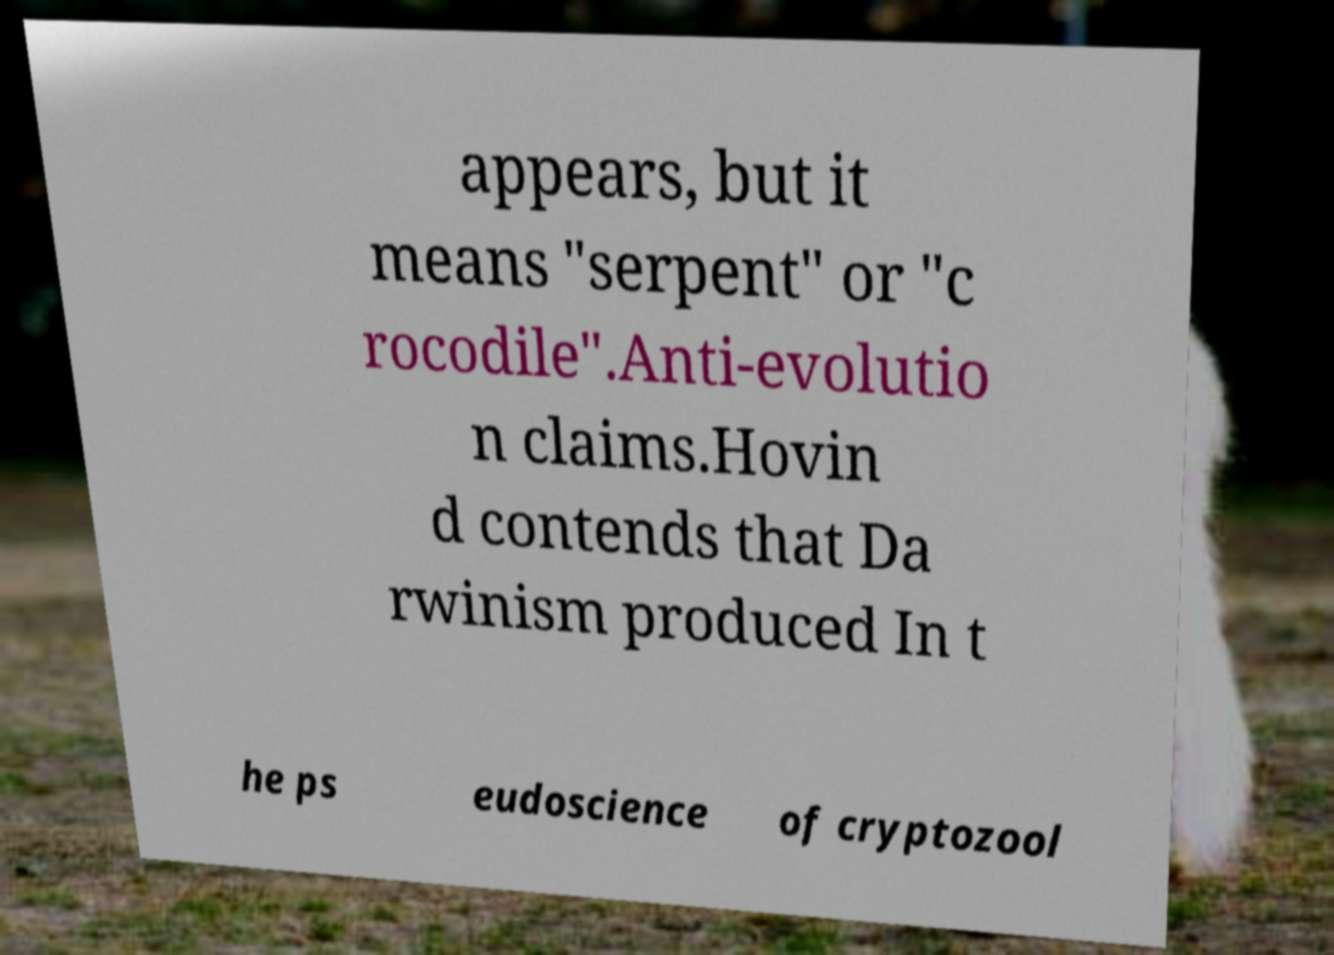Could you extract and type out the text from this image? appears, but it means "serpent" or "c rocodile".Anti-evolutio n claims.Hovin d contends that Da rwinism produced In t he ps eudoscience of cryptozool 